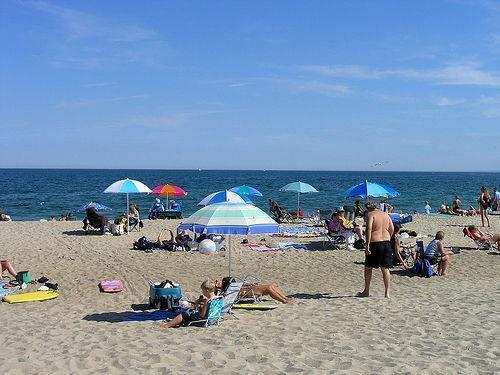How many men standing with black shorts?
Give a very brief answer. 1. 